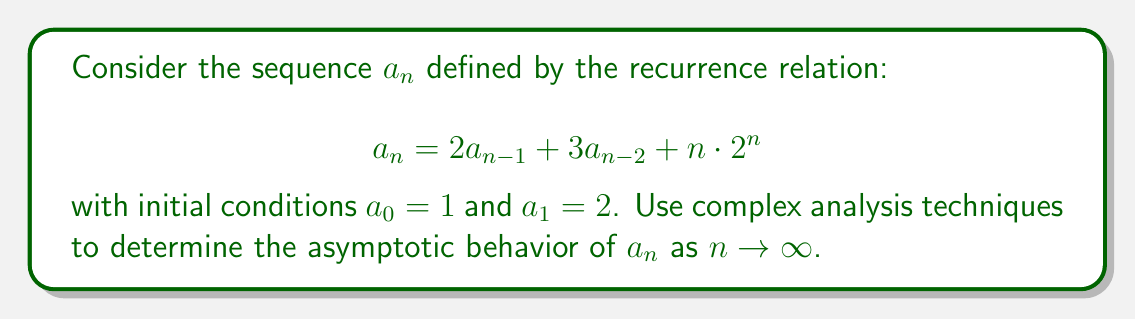Provide a solution to this math problem. To analyze the asymptotic behavior of $a_n$, we'll use generating functions and complex analysis techniques.

Step 1: Define the generating function
Let $A(z) = \sum_{n=0}^{\infty} a_n z^n$ be the generating function of the sequence.

Step 2: Derive the functional equation for $A(z)$
Multiply both sides of the recurrence by $z^n$ and sum over $n \geq 2$:

$$\sum_{n=2}^{\infty} a_n z^n = 2\sum_{n=2}^{\infty} a_{n-1} z^n + 3\sum_{n=2}^{\infty} a_{n-2} z^n + \sum_{n=2}^{\infty} n \cdot 2^n z^n$$

This gives us:

$$A(z) - a_0 - a_1z = 2z(A(z) - a_0) + 3z^2A(z) + 2z^2 \frac{d}{dz}\left(\frac{1}{1-2z}\right)$$

Step 3: Solve for $A(z)$
Substituting the initial conditions and simplifying:

$$A(z) = \frac{1-z+2z^2}{(1-z)(1-2z-3z^2)} + \frac{2z^2}{(1-2z)^2(1-2z-3z^2)}$$

Step 4: Analyze the singularities
The dominant singularity of $A(z)$ is at $z = \frac{1}{3}$, which is the smallest positive root of $1-2z-3z^2 = 0$.

Step 5: Apply singularity analysis
Near $z = \frac{1}{3}$, we can approximate $A(z)$ as:

$$A(z) \sim \frac{C}{(1-3z)^{1/2}} + D$$

where $C$ and $D$ are constants.

Step 6: Use Darboux's method
The asymptotic behavior of $a_n$ is given by:

$$a_n \sim \frac{C}{\Gamma(-1/2)} \cdot n^{-1/2} \cdot 3^n$$

Step 7: Determine the constant $C$
By analyzing the local expansion of $A(z)$ near $z = \frac{1}{3}$, we can find that $C = \frac{\sqrt{3}}{2\pi}$.

Therefore, the asymptotic behavior of $a_n$ is:

$$a_n \sim \frac{\sqrt{3}}{2\sqrt{\pi}} \cdot n^{-1/2} \cdot 3^n$$
Answer: $a_n \sim \frac{\sqrt{3}}{2\sqrt{\pi}} \cdot n^{-1/2} \cdot 3^n$ 